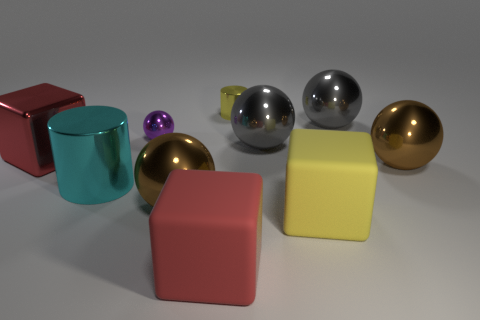There is a object that is the same color as the small shiny cylinder; what is its shape?
Offer a very short reply. Cube. There is a cyan metal object that is the same shape as the yellow metallic object; what size is it?
Your answer should be very brief. Large. The other shiny object that is the same shape as the cyan thing is what color?
Your response must be concise. Yellow. Is there anything else that is the same shape as the tiny purple shiny object?
Give a very brief answer. Yes. Are there any brown metallic things that are to the left of the gray shiny ball to the right of the big gray metallic object that is to the left of the yellow matte object?
Your answer should be compact. Yes. What number of large gray things are made of the same material as the tiny yellow object?
Keep it short and to the point. 2. Is the size of the thing that is on the left side of the big cyan metal thing the same as the red thing to the right of the cyan thing?
Provide a short and direct response. Yes. What is the color of the large cylinder in front of the gray object that is in front of the big thing that is behind the purple metallic thing?
Provide a succinct answer. Cyan. Are there any other objects of the same shape as the large yellow thing?
Your answer should be very brief. Yes. Are there an equal number of large gray spheres left of the large red metallic object and gray things on the left side of the cyan cylinder?
Your response must be concise. Yes. 